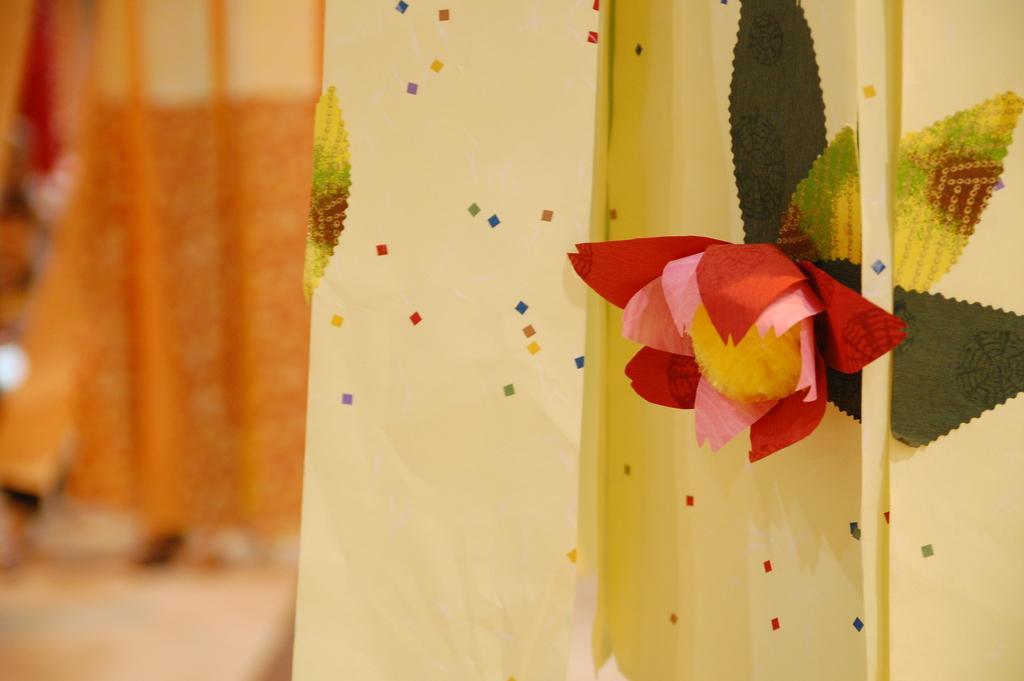Describe this image in one or two sentences. In this image I can see a flower in red, pink and yellow color and leaves in green color. Background the wall is in lite yellow color and I can see an orange color curtain. 